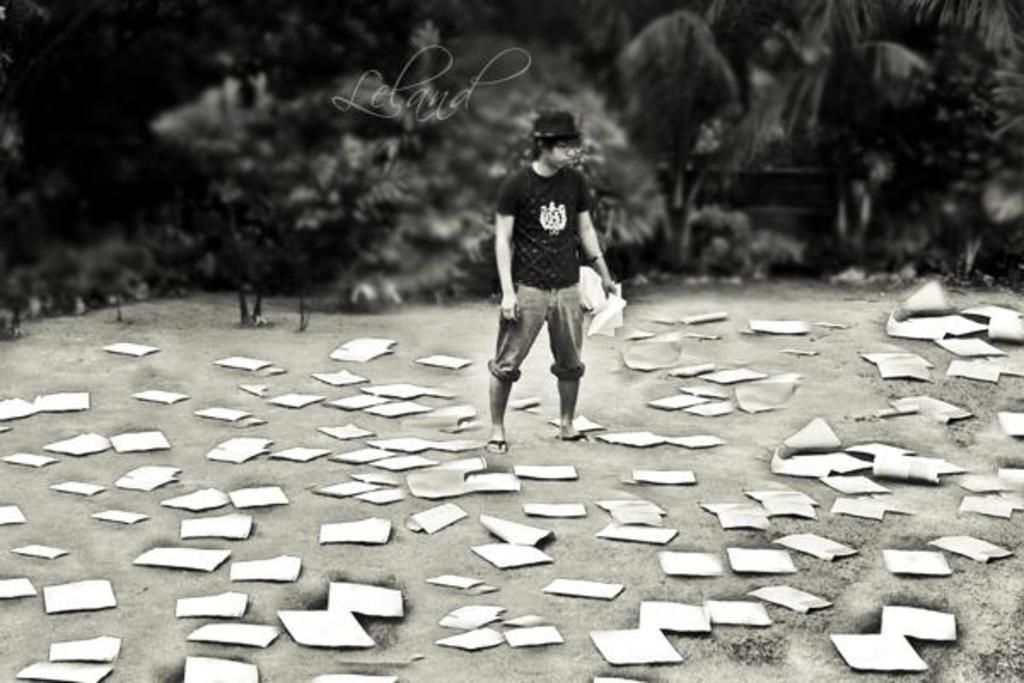Please provide a concise description of this image. In this picture we can see a man wore a cap, holding papers with his hand, standing and in front of him we can see papers on the ground and in the background we can see trees. 